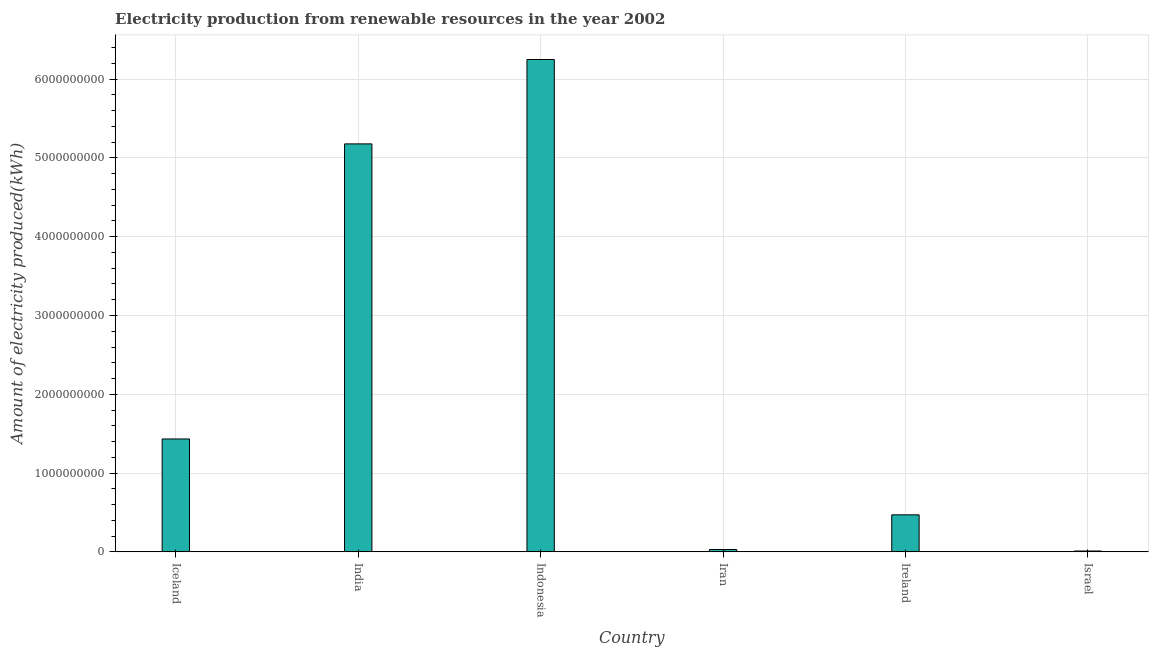Does the graph contain any zero values?
Provide a short and direct response. No. What is the title of the graph?
Ensure brevity in your answer.  Electricity production from renewable resources in the year 2002. What is the label or title of the Y-axis?
Offer a very short reply. Amount of electricity produced(kWh). What is the amount of electricity produced in Israel?
Keep it short and to the point. 1.10e+07. Across all countries, what is the maximum amount of electricity produced?
Offer a very short reply. 6.25e+09. Across all countries, what is the minimum amount of electricity produced?
Provide a succinct answer. 1.10e+07. In which country was the amount of electricity produced maximum?
Give a very brief answer. Indonesia. What is the sum of the amount of electricity produced?
Your answer should be very brief. 1.34e+1. What is the difference between the amount of electricity produced in Ireland and Israel?
Offer a very short reply. 4.59e+08. What is the average amount of electricity produced per country?
Offer a very short reply. 2.23e+09. What is the median amount of electricity produced?
Keep it short and to the point. 9.52e+08. What is the ratio of the amount of electricity produced in Ireland to that in Israel?
Provide a succinct answer. 42.73. What is the difference between the highest and the second highest amount of electricity produced?
Offer a terse response. 1.07e+09. Is the sum of the amount of electricity produced in Iran and Israel greater than the maximum amount of electricity produced across all countries?
Your answer should be very brief. No. What is the difference between the highest and the lowest amount of electricity produced?
Your answer should be compact. 6.24e+09. What is the Amount of electricity produced(kWh) of Iceland?
Your answer should be compact. 1.43e+09. What is the Amount of electricity produced(kWh) in India?
Ensure brevity in your answer.  5.18e+09. What is the Amount of electricity produced(kWh) in Indonesia?
Offer a terse response. 6.25e+09. What is the Amount of electricity produced(kWh) in Iran?
Provide a succinct answer. 3.00e+07. What is the Amount of electricity produced(kWh) of Ireland?
Provide a succinct answer. 4.70e+08. What is the Amount of electricity produced(kWh) in Israel?
Give a very brief answer. 1.10e+07. What is the difference between the Amount of electricity produced(kWh) in Iceland and India?
Your response must be concise. -3.74e+09. What is the difference between the Amount of electricity produced(kWh) in Iceland and Indonesia?
Provide a succinct answer. -4.82e+09. What is the difference between the Amount of electricity produced(kWh) in Iceland and Iran?
Provide a succinct answer. 1.40e+09. What is the difference between the Amount of electricity produced(kWh) in Iceland and Ireland?
Your answer should be very brief. 9.63e+08. What is the difference between the Amount of electricity produced(kWh) in Iceland and Israel?
Ensure brevity in your answer.  1.42e+09. What is the difference between the Amount of electricity produced(kWh) in India and Indonesia?
Provide a short and direct response. -1.07e+09. What is the difference between the Amount of electricity produced(kWh) in India and Iran?
Your answer should be compact. 5.15e+09. What is the difference between the Amount of electricity produced(kWh) in India and Ireland?
Offer a very short reply. 4.71e+09. What is the difference between the Amount of electricity produced(kWh) in India and Israel?
Your answer should be very brief. 5.17e+09. What is the difference between the Amount of electricity produced(kWh) in Indonesia and Iran?
Make the answer very short. 6.22e+09. What is the difference between the Amount of electricity produced(kWh) in Indonesia and Ireland?
Provide a succinct answer. 5.78e+09. What is the difference between the Amount of electricity produced(kWh) in Indonesia and Israel?
Provide a succinct answer. 6.24e+09. What is the difference between the Amount of electricity produced(kWh) in Iran and Ireland?
Make the answer very short. -4.40e+08. What is the difference between the Amount of electricity produced(kWh) in Iran and Israel?
Offer a very short reply. 1.90e+07. What is the difference between the Amount of electricity produced(kWh) in Ireland and Israel?
Give a very brief answer. 4.59e+08. What is the ratio of the Amount of electricity produced(kWh) in Iceland to that in India?
Your answer should be compact. 0.28. What is the ratio of the Amount of electricity produced(kWh) in Iceland to that in Indonesia?
Your response must be concise. 0.23. What is the ratio of the Amount of electricity produced(kWh) in Iceland to that in Iran?
Offer a terse response. 47.77. What is the ratio of the Amount of electricity produced(kWh) in Iceland to that in Ireland?
Make the answer very short. 3.05. What is the ratio of the Amount of electricity produced(kWh) in Iceland to that in Israel?
Provide a succinct answer. 130.27. What is the ratio of the Amount of electricity produced(kWh) in India to that in Indonesia?
Offer a terse response. 0.83. What is the ratio of the Amount of electricity produced(kWh) in India to that in Iran?
Your answer should be very brief. 172.6. What is the ratio of the Amount of electricity produced(kWh) in India to that in Ireland?
Give a very brief answer. 11.02. What is the ratio of the Amount of electricity produced(kWh) in India to that in Israel?
Give a very brief answer. 470.73. What is the ratio of the Amount of electricity produced(kWh) in Indonesia to that in Iran?
Make the answer very short. 208.3. What is the ratio of the Amount of electricity produced(kWh) in Indonesia to that in Ireland?
Offer a very short reply. 13.3. What is the ratio of the Amount of electricity produced(kWh) in Indonesia to that in Israel?
Offer a very short reply. 568.09. What is the ratio of the Amount of electricity produced(kWh) in Iran to that in Ireland?
Keep it short and to the point. 0.06. What is the ratio of the Amount of electricity produced(kWh) in Iran to that in Israel?
Give a very brief answer. 2.73. What is the ratio of the Amount of electricity produced(kWh) in Ireland to that in Israel?
Your answer should be very brief. 42.73. 